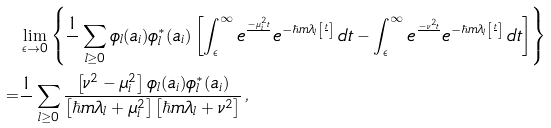Convert formula to latex. <formula><loc_0><loc_0><loc_500><loc_500>& \lim _ { \epsilon \rightarrow 0 } \left \{ \frac { 1 } { } \sum _ { l \geq 0 } \phi _ { l } ( a _ { i } ) \phi _ { l } ^ { * } ( a _ { i } ) \left [ \int _ { \epsilon } ^ { \infty } e ^ { \frac { - \mu _ { i } ^ { 2 } t } { } } e ^ { - \hbar { m } \lambda _ { l } \left [ \frac { t } { } \right ] } \, d t - \int _ { \epsilon } ^ { \infty } e ^ { \frac { - \nu ^ { 2 } t } { } } e ^ { - \hbar { m } \lambda _ { l } \left [ \frac { t } { } \right ] } \, d t \right ] \right \} \\ = & \frac { 1 } { } \sum _ { l \geq 0 } \frac { \left [ \nu ^ { 2 } - \mu _ { i } ^ { 2 } \right ] \phi _ { l } ( a _ { i } ) \phi _ { l } ^ { * } ( a _ { i } ) } { \left [ \hbar { m } \lambda _ { l } + \mu _ { i } ^ { 2 } \right ] \left [ \hbar { m } \lambda _ { l } + \nu ^ { 2 } \right ] } \, ,</formula> 